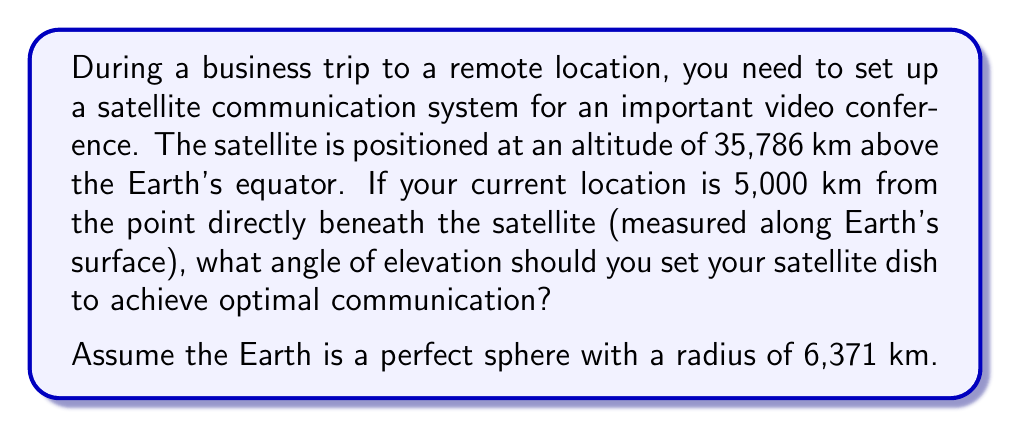Provide a solution to this math problem. To solve this problem, we need to use trigonometry in a right-angled triangle. Let's break it down step-by-step:

1) First, let's visualize the problem:

[asy]
import geometry;

pair O = (0,0);
pair E = (5,0);
pair S = (0,7);

draw(O--E--S--O);
draw(E--S,dashed);

label("O (Earth's center)", O, SW);
label("E (Your location)", E, SE);
label("S (Satellite)", S, N);

label("r", (O--E)/2, S);
label("h", (0,3.5), W);
label("d", (2.5,0), S);
label("$\theta$", E, NW);

draw(arc(E,0.5,0,angle(S-E)), Arrow);
[/asy]

2) In this diagram:
   - O is the center of the Earth
   - E is your location
   - S is the satellite
   - r is the Earth's radius (6,371 km)
   - h is the satellite's altitude (35,786 km)
   - d is the distance along Earth's surface to the point beneath the satellite (5,000 km)
   - $\theta$ is the angle of elevation we're looking for

3) We need to find the angle $\theta$ in the right-angled triangle EFS, where F is the point directly above E at the same altitude as S.

4) To do this, we first need to find the length of EF and FS:

   EF = $\sqrt{(r + h)^2 - (r + \frac{d}{r}\cdot r)^2}$
      = $\sqrt{(6371 + 35786)^2 - (6371 + 5000)^2}$
      = 35,678.5 km

   FS = 5,000 km

5) Now we can use the arctangent function to find $\theta$:

   $$\theta = \arctan(\frac{EF}{FS}) = \arctan(\frac{35678.5}{5000})$$

6) Calculating this:

   $$\theta = \arctan(7.13569) = 82.03^\circ$$

Therefore, the angle of elevation should be set to approximately 82.03°.
Answer: $82.03^\circ$ 